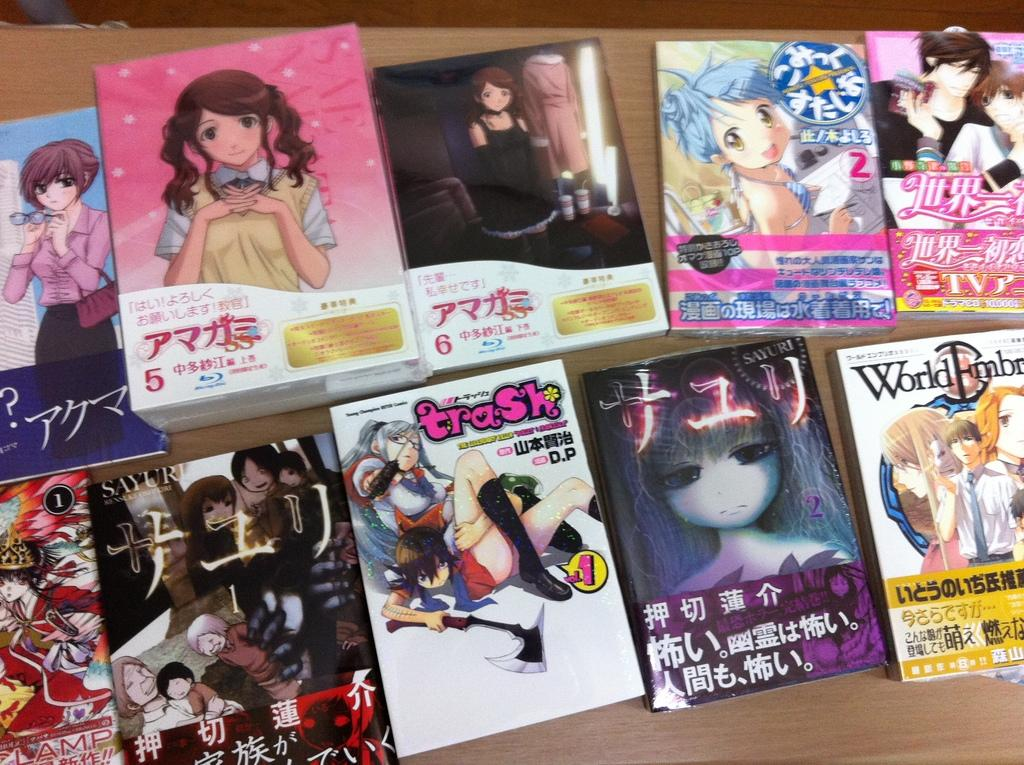What objects are present in the image? There are books in the image. Where are the books located? The books are on a wooden platform. Is there a lamp made of cork in the image? There is no lamp or cork present in the image. 